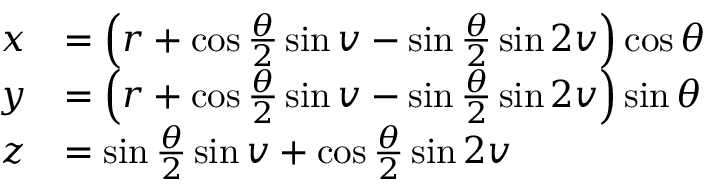<formula> <loc_0><loc_0><loc_500><loc_500>{ \begin{array} { r l } { x } & { = \left ( r + \cos { \frac { \theta } { 2 } } \sin v - \sin { \frac { \theta } { 2 } } \sin 2 v \right ) \cos \theta } \\ { y } & { = \left ( r + \cos { \frac { \theta } { 2 } } \sin v - \sin { \frac { \theta } { 2 } } \sin 2 v \right ) \sin \theta } \\ { z } & { = \sin { \frac { \theta } { 2 } } \sin v + \cos { \frac { \theta } { 2 } } \sin 2 v } \end{array} }</formula> 